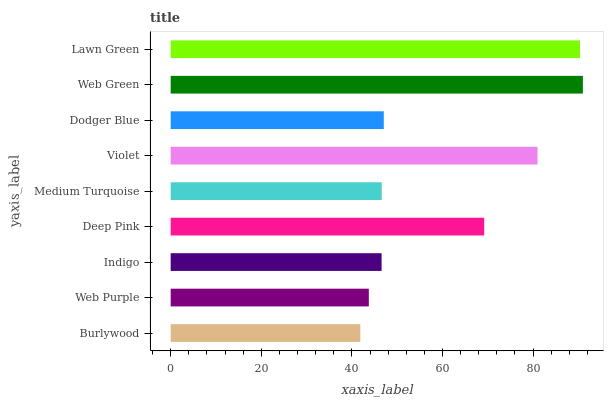Is Burlywood the minimum?
Answer yes or no. Yes. Is Web Green the maximum?
Answer yes or no. Yes. Is Web Purple the minimum?
Answer yes or no. No. Is Web Purple the maximum?
Answer yes or no. No. Is Web Purple greater than Burlywood?
Answer yes or no. Yes. Is Burlywood less than Web Purple?
Answer yes or no. Yes. Is Burlywood greater than Web Purple?
Answer yes or no. No. Is Web Purple less than Burlywood?
Answer yes or no. No. Is Dodger Blue the high median?
Answer yes or no. Yes. Is Dodger Blue the low median?
Answer yes or no. Yes. Is Medium Turquoise the high median?
Answer yes or no. No. Is Lawn Green the low median?
Answer yes or no. No. 